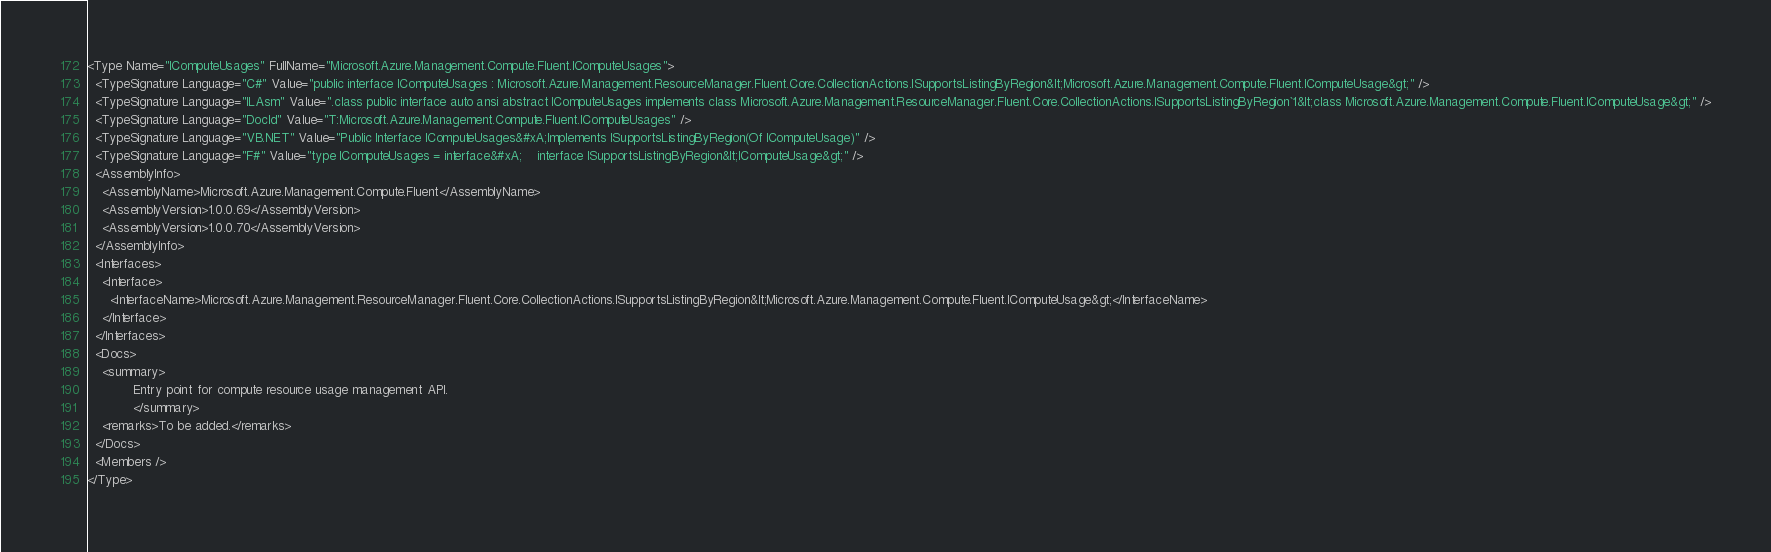<code> <loc_0><loc_0><loc_500><loc_500><_XML_><Type Name="IComputeUsages" FullName="Microsoft.Azure.Management.Compute.Fluent.IComputeUsages">
  <TypeSignature Language="C#" Value="public interface IComputeUsages : Microsoft.Azure.Management.ResourceManager.Fluent.Core.CollectionActions.ISupportsListingByRegion&lt;Microsoft.Azure.Management.Compute.Fluent.IComputeUsage&gt;" />
  <TypeSignature Language="ILAsm" Value=".class public interface auto ansi abstract IComputeUsages implements class Microsoft.Azure.Management.ResourceManager.Fluent.Core.CollectionActions.ISupportsListingByRegion`1&lt;class Microsoft.Azure.Management.Compute.Fluent.IComputeUsage&gt;" />
  <TypeSignature Language="DocId" Value="T:Microsoft.Azure.Management.Compute.Fluent.IComputeUsages" />
  <TypeSignature Language="VB.NET" Value="Public Interface IComputeUsages&#xA;Implements ISupportsListingByRegion(Of IComputeUsage)" />
  <TypeSignature Language="F#" Value="type IComputeUsages = interface&#xA;    interface ISupportsListingByRegion&lt;IComputeUsage&gt;" />
  <AssemblyInfo>
    <AssemblyName>Microsoft.Azure.Management.Compute.Fluent</AssemblyName>
    <AssemblyVersion>1.0.0.69</AssemblyVersion>
    <AssemblyVersion>1.0.0.70</AssemblyVersion>
  </AssemblyInfo>
  <Interfaces>
    <Interface>
      <InterfaceName>Microsoft.Azure.Management.ResourceManager.Fluent.Core.CollectionActions.ISupportsListingByRegion&lt;Microsoft.Azure.Management.Compute.Fluent.IComputeUsage&gt;</InterfaceName>
    </Interface>
  </Interfaces>
  <Docs>
    <summary>
            Entry point for compute resource usage management API.
            </summary>
    <remarks>To be added.</remarks>
  </Docs>
  <Members />
</Type>
</code> 